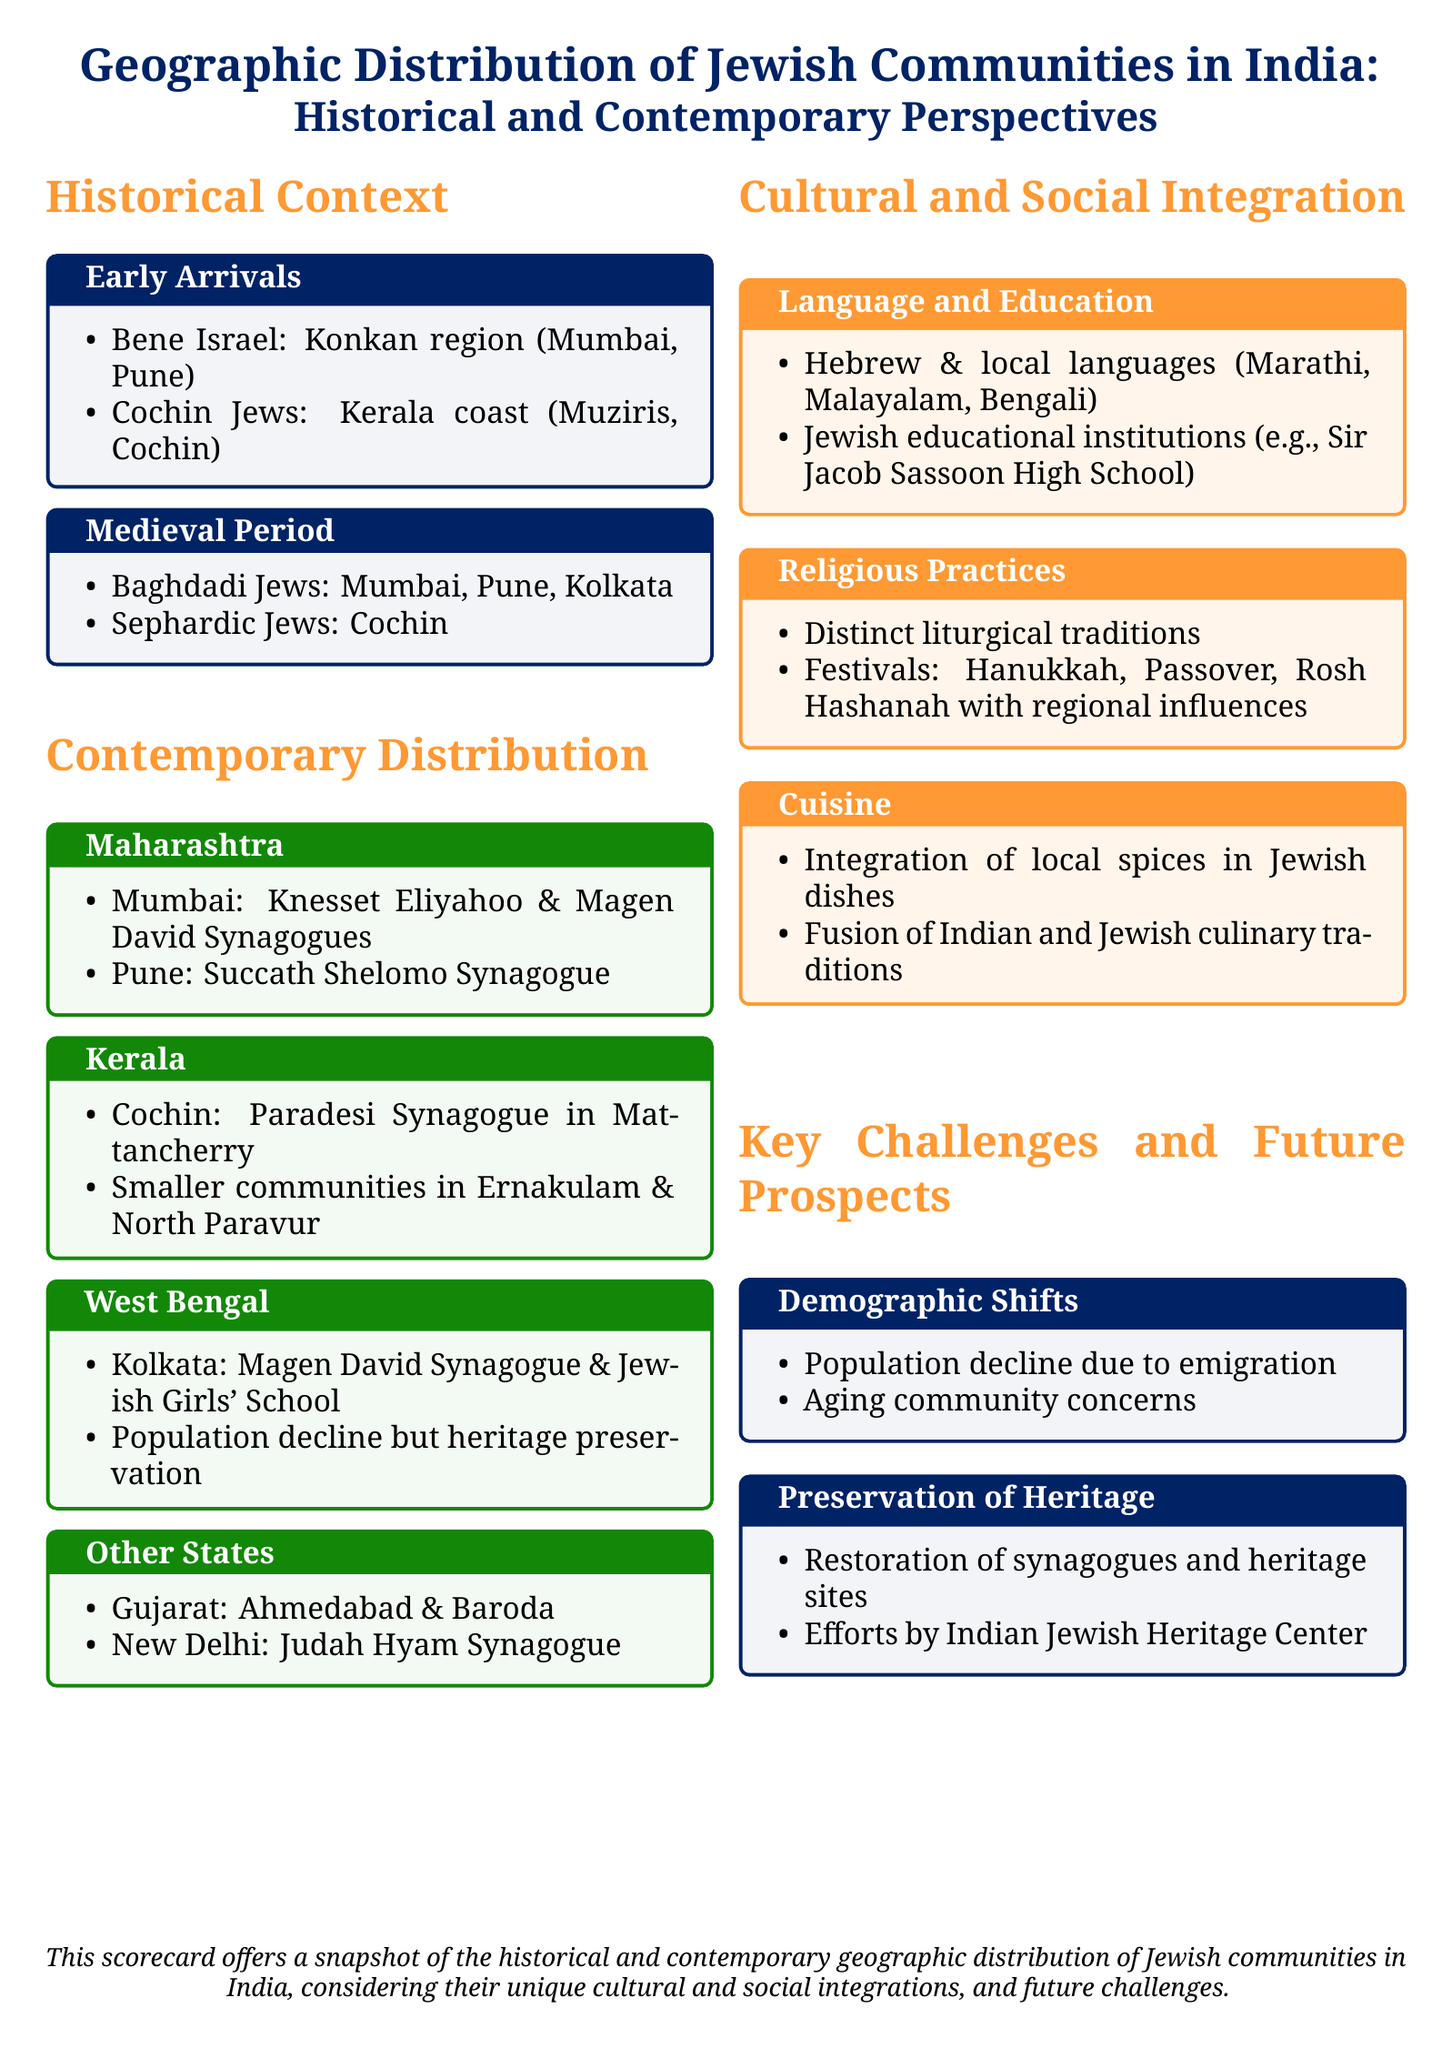What are the two major regions where the Bene Israel community is found? The document lists the Konkan region as one major area along with Mumbai and Pune for the Bene Israel community.
Answer: Konkan region, Mumbai, Pune Which Jewish community is associated with Kerala? The document mentions the Cochin Jews as the specific community tied to Kerala.
Answer: Cochin Jews What is the name of the synagogue located in Mumbai? The document provides the names of notable synagogues in Mumbai, specifically naming Knesset Eliyahoo and Magen David Synagogues.
Answer: Knesset Eliyahoo, Magen David What are the two challenges mentioned regarding the Jewish communities in India? The text lists demographic shifts and preservation of heritage as the two main challenges faced by these communities.
Answer: Demographic shifts, Preservation of heritage In how many states are Jewish communities mentioned in the document? The document references the distribution of Jewish communities in multiple states, specifically naming Maharashtra, Kerala, West Bengal, Gujarat, and New Delhi.
Answer: Five states What is a significant cultural integration aspect highlighted for Jewish communities? The document discusses language and education as a critical area of cultural integration for Jewish communities in India.
Answer: Language and education What historical group is indicated as having arrived during the medieval period? The document specifies Baghdadi Jews and Sephardic Jews as the historical groups that came during the medieval period.
Answer: Baghdadi Jews, Sephardic Jews What is the name of the synagogue located in New Delhi? The document specifically mentions Judah Hyam Synagogue as a notable place in New Delhi.
Answer: Judah Hyam Synagogue Which institution is mentioned as part of Jewish education? The document refers to Sir Jacob Sassoon High School as an example of Jewish educational institutions in India.
Answer: Sir Jacob Sassoon High School 